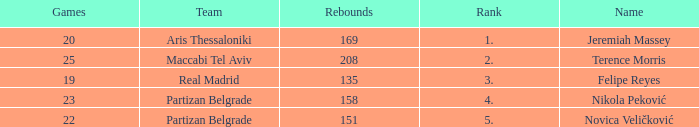What is the number of Games for the Maccabi Tel Aviv Team with less than 208 Rebounds? None. 